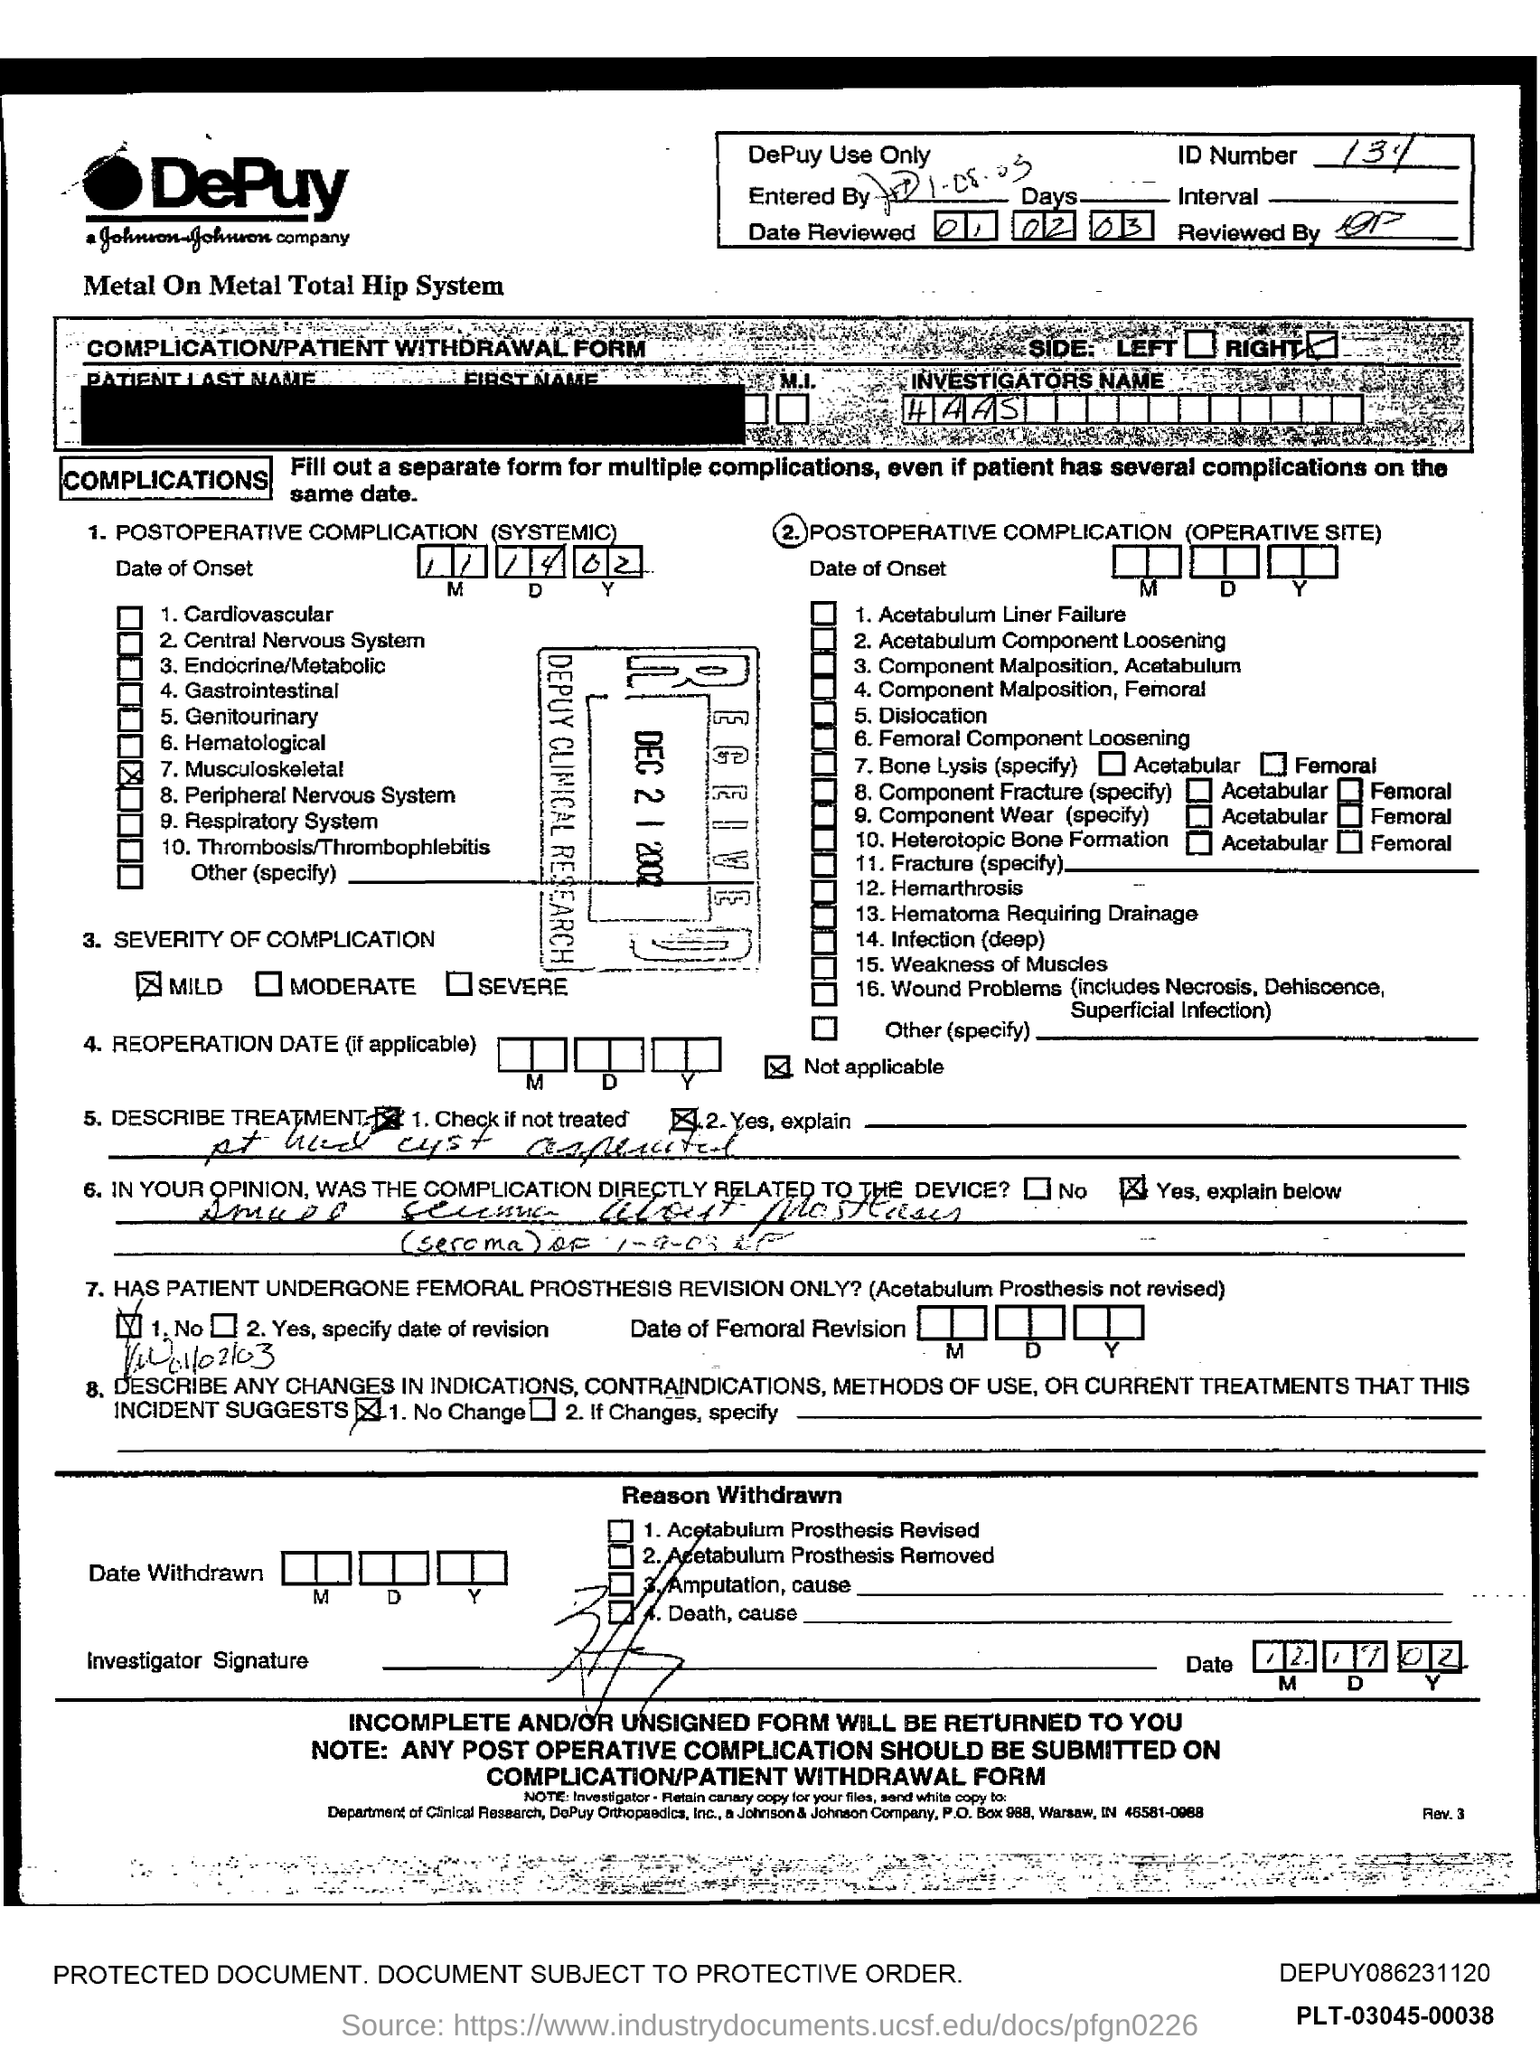What is name of Investigator?
Provide a short and direct response. Haas. 